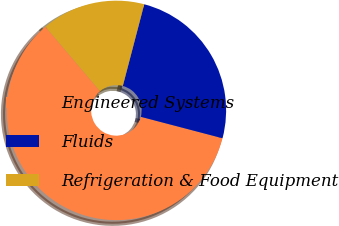<chart> <loc_0><loc_0><loc_500><loc_500><pie_chart><fcel>Engineered Systems<fcel>Fluids<fcel>Refrigeration & Food Equipment<nl><fcel>59.72%<fcel>25.0%<fcel>15.28%<nl></chart> 